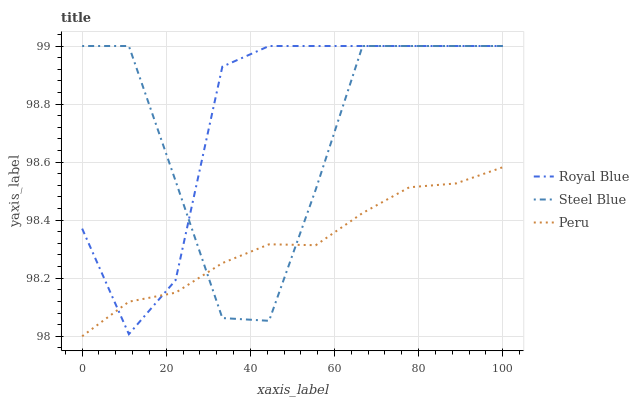Does Steel Blue have the minimum area under the curve?
Answer yes or no. No. Does Steel Blue have the maximum area under the curve?
Answer yes or no. No. Is Steel Blue the smoothest?
Answer yes or no. No. Is Peru the roughest?
Answer yes or no. No. Does Steel Blue have the lowest value?
Answer yes or no. No. Does Peru have the highest value?
Answer yes or no. No. 